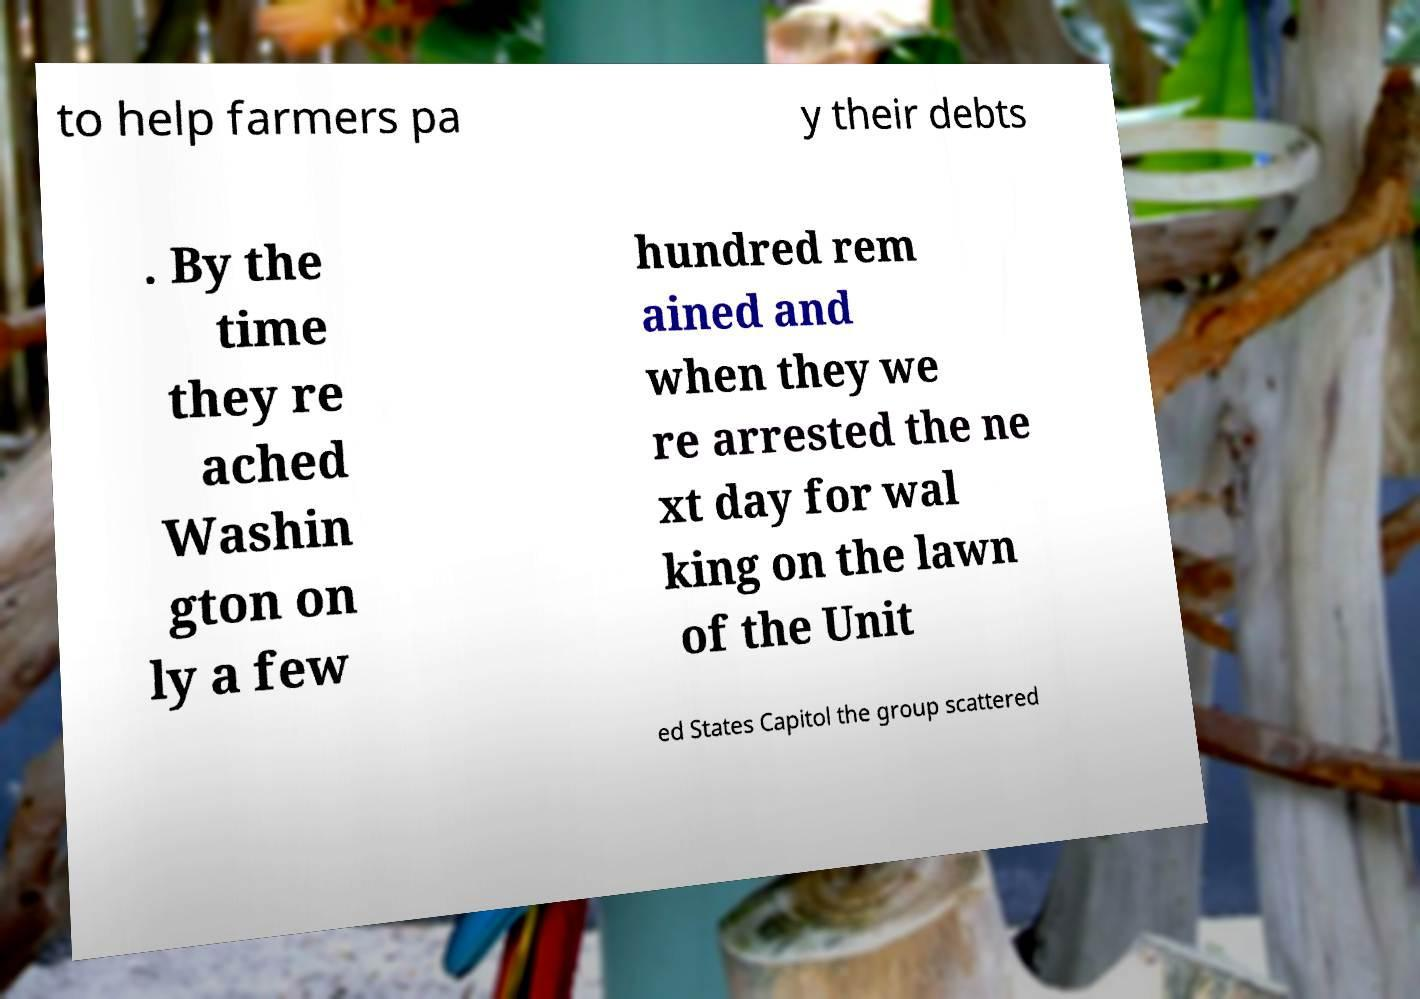Please read and relay the text visible in this image. What does it say? to help farmers pa y their debts . By the time they re ached Washin gton on ly a few hundred rem ained and when they we re arrested the ne xt day for wal king on the lawn of the Unit ed States Capitol the group scattered 